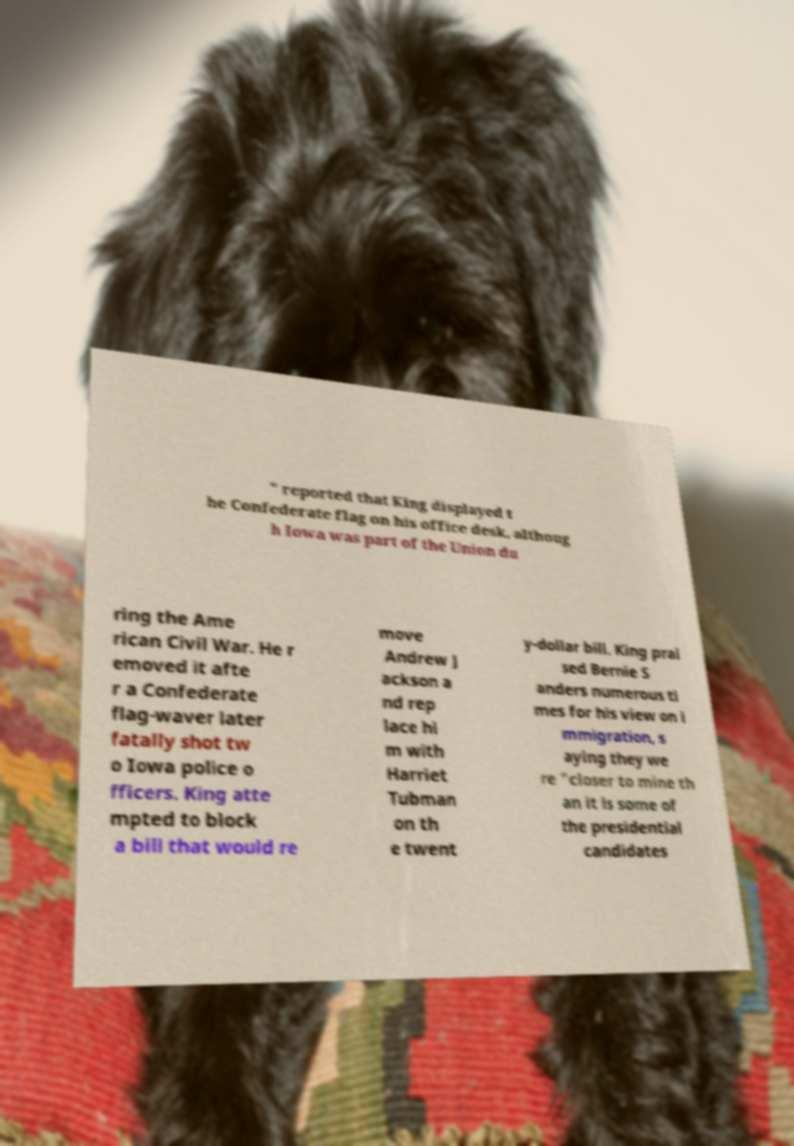Can you read and provide the text displayed in the image?This photo seems to have some interesting text. Can you extract and type it out for me? " reported that King displayed t he Confederate flag on his office desk, althoug h Iowa was part of the Union du ring the Ame rican Civil War. He r emoved it afte r a Confederate flag-waver later fatally shot tw o Iowa police o fficers. King atte mpted to block a bill that would re move Andrew J ackson a nd rep lace hi m with Harriet Tubman on th e twent y-dollar bill. King prai sed Bernie S anders numerous ti mes for his view on i mmigration, s aying they we re "closer to mine th an it is some of the presidential candidates 